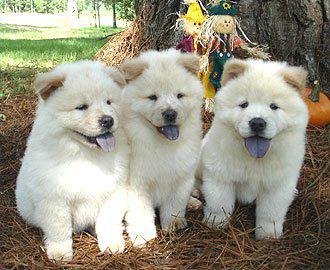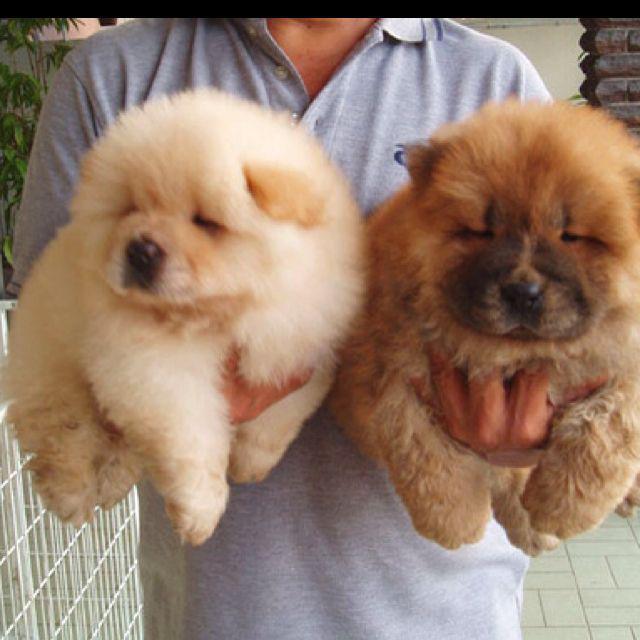The first image is the image on the left, the second image is the image on the right. Considering the images on both sides, is "There are no more than 3 dogs." valid? Answer yes or no. No. The first image is the image on the left, the second image is the image on the right. Examine the images to the left and right. Is the description "There is at most 3 dogs." accurate? Answer yes or no. No. 